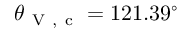<formula> <loc_0><loc_0><loc_500><loc_500>\theta _ { V , c } = 1 2 1 . 3 9 ^ { \circ }</formula> 